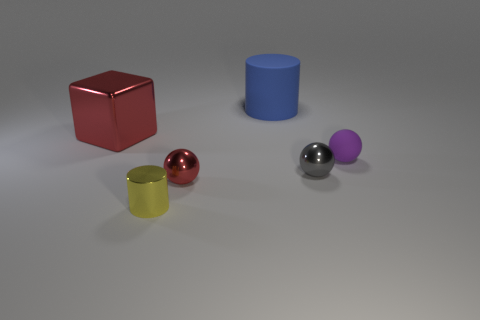Add 4 small purple rubber balls. How many objects exist? 10 Subtract all cylinders. How many objects are left? 4 Subtract 1 blue cylinders. How many objects are left? 5 Subtract all yellow metal things. Subtract all metallic spheres. How many objects are left? 3 Add 3 gray metal balls. How many gray metal balls are left? 4 Add 3 balls. How many balls exist? 6 